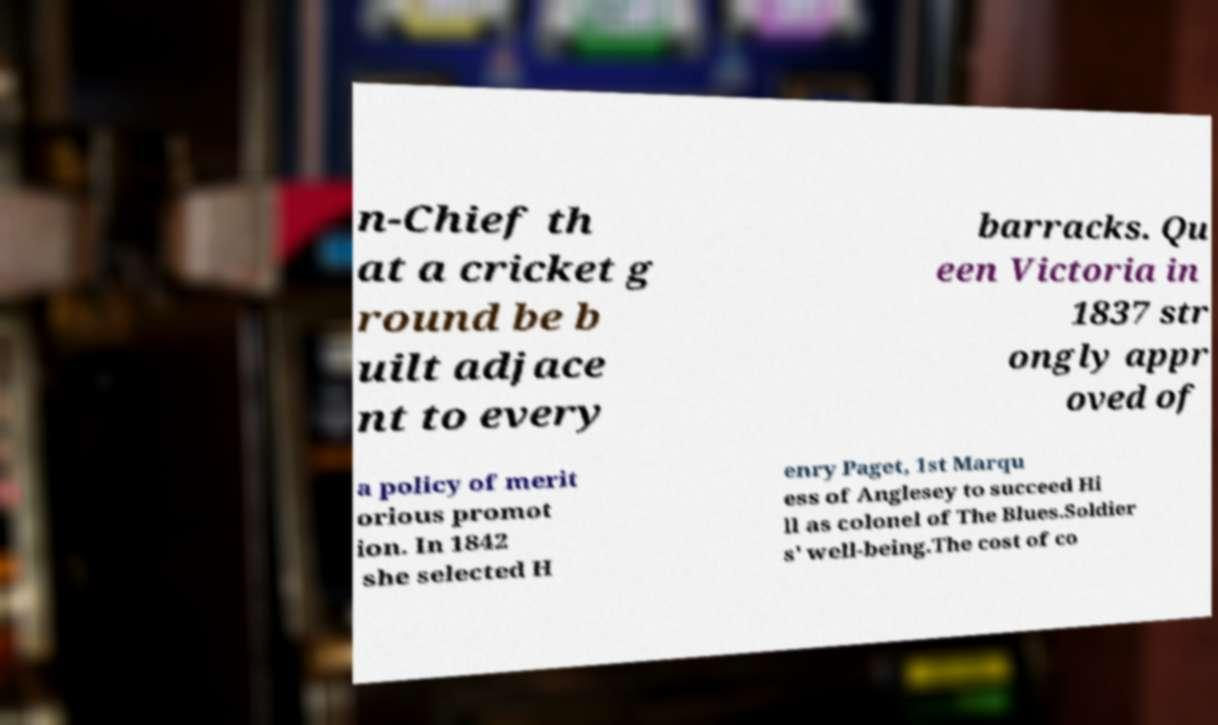Could you assist in decoding the text presented in this image and type it out clearly? n-Chief th at a cricket g round be b uilt adjace nt to every barracks. Qu een Victoria in 1837 str ongly appr oved of a policy of merit orious promot ion. In 1842 she selected H enry Paget, 1st Marqu ess of Anglesey to succeed Hi ll as colonel of The Blues.Soldier s' well-being.The cost of co 